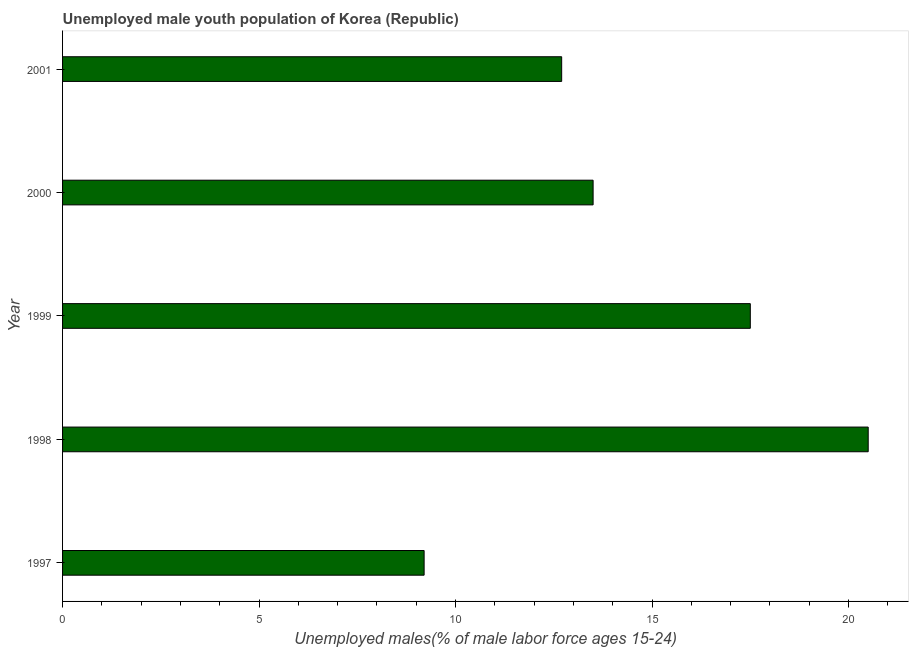Does the graph contain grids?
Make the answer very short. No. What is the title of the graph?
Offer a terse response. Unemployed male youth population of Korea (Republic). What is the label or title of the X-axis?
Keep it short and to the point. Unemployed males(% of male labor force ages 15-24). Across all years, what is the maximum unemployed male youth?
Make the answer very short. 20.5. Across all years, what is the minimum unemployed male youth?
Provide a succinct answer. 9.2. What is the sum of the unemployed male youth?
Offer a terse response. 73.4. What is the average unemployed male youth per year?
Provide a succinct answer. 14.68. In how many years, is the unemployed male youth greater than 14 %?
Your response must be concise. 2. What is the ratio of the unemployed male youth in 1999 to that in 2000?
Your answer should be compact. 1.3. Is the difference between the unemployed male youth in 1998 and 2001 greater than the difference between any two years?
Your answer should be compact. No. What is the difference between the highest and the second highest unemployed male youth?
Give a very brief answer. 3. In how many years, is the unemployed male youth greater than the average unemployed male youth taken over all years?
Offer a terse response. 2. Are the values on the major ticks of X-axis written in scientific E-notation?
Offer a terse response. No. What is the Unemployed males(% of male labor force ages 15-24) in 1997?
Your answer should be compact. 9.2. What is the Unemployed males(% of male labor force ages 15-24) in 1998?
Your answer should be very brief. 20.5. What is the Unemployed males(% of male labor force ages 15-24) of 1999?
Give a very brief answer. 17.5. What is the Unemployed males(% of male labor force ages 15-24) of 2001?
Offer a very short reply. 12.7. What is the difference between the Unemployed males(% of male labor force ages 15-24) in 1997 and 1998?
Your response must be concise. -11.3. What is the difference between the Unemployed males(% of male labor force ages 15-24) in 1997 and 2001?
Offer a very short reply. -3.5. What is the difference between the Unemployed males(% of male labor force ages 15-24) in 1998 and 2001?
Provide a succinct answer. 7.8. What is the ratio of the Unemployed males(% of male labor force ages 15-24) in 1997 to that in 1998?
Offer a very short reply. 0.45. What is the ratio of the Unemployed males(% of male labor force ages 15-24) in 1997 to that in 1999?
Ensure brevity in your answer.  0.53. What is the ratio of the Unemployed males(% of male labor force ages 15-24) in 1997 to that in 2000?
Make the answer very short. 0.68. What is the ratio of the Unemployed males(% of male labor force ages 15-24) in 1997 to that in 2001?
Ensure brevity in your answer.  0.72. What is the ratio of the Unemployed males(% of male labor force ages 15-24) in 1998 to that in 1999?
Offer a terse response. 1.17. What is the ratio of the Unemployed males(% of male labor force ages 15-24) in 1998 to that in 2000?
Give a very brief answer. 1.52. What is the ratio of the Unemployed males(% of male labor force ages 15-24) in 1998 to that in 2001?
Make the answer very short. 1.61. What is the ratio of the Unemployed males(% of male labor force ages 15-24) in 1999 to that in 2000?
Make the answer very short. 1.3. What is the ratio of the Unemployed males(% of male labor force ages 15-24) in 1999 to that in 2001?
Make the answer very short. 1.38. What is the ratio of the Unemployed males(% of male labor force ages 15-24) in 2000 to that in 2001?
Provide a short and direct response. 1.06. 